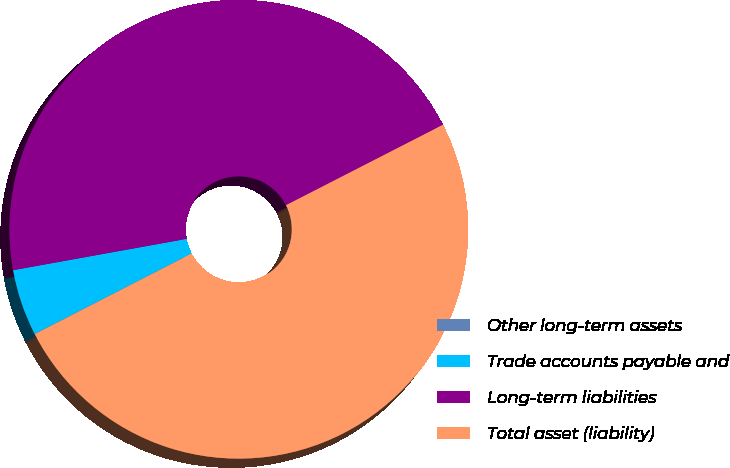Convert chart to OTSL. <chart><loc_0><loc_0><loc_500><loc_500><pie_chart><fcel>Other long-term assets<fcel>Trade accounts payable and<fcel>Long-term liabilities<fcel>Total asset (liability)<nl><fcel>0.01%<fcel>4.69%<fcel>45.31%<fcel>49.99%<nl></chart> 